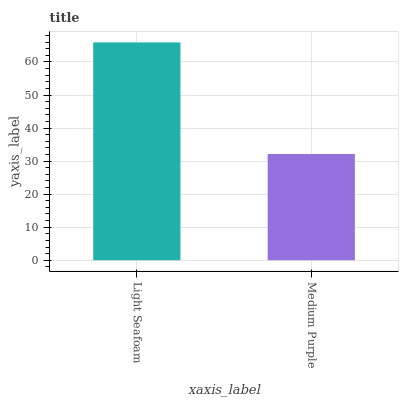Is Medium Purple the minimum?
Answer yes or no. Yes. Is Light Seafoam the maximum?
Answer yes or no. Yes. Is Medium Purple the maximum?
Answer yes or no. No. Is Light Seafoam greater than Medium Purple?
Answer yes or no. Yes. Is Medium Purple less than Light Seafoam?
Answer yes or no. Yes. Is Medium Purple greater than Light Seafoam?
Answer yes or no. No. Is Light Seafoam less than Medium Purple?
Answer yes or no. No. Is Light Seafoam the high median?
Answer yes or no. Yes. Is Medium Purple the low median?
Answer yes or no. Yes. Is Medium Purple the high median?
Answer yes or no. No. Is Light Seafoam the low median?
Answer yes or no. No. 